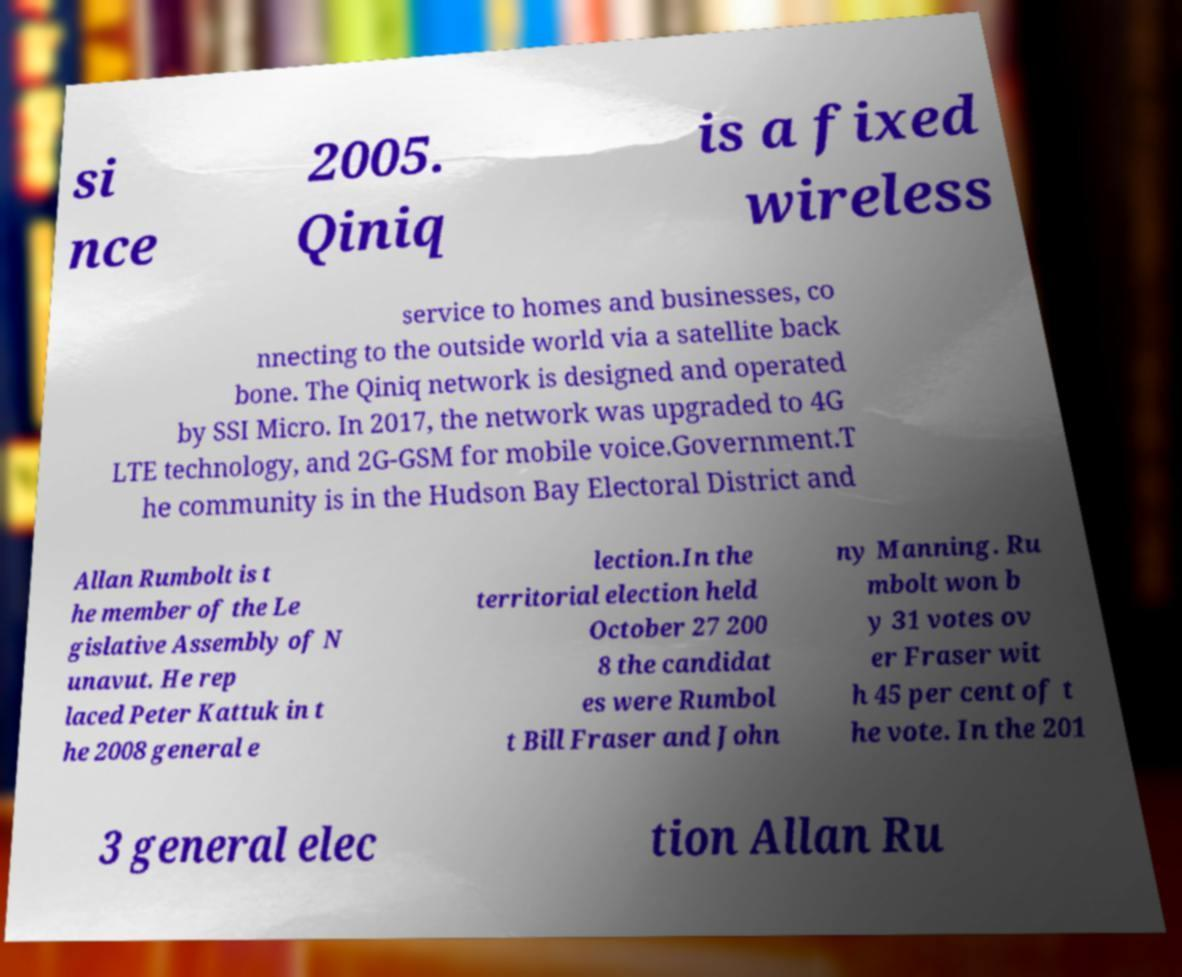Could you extract and type out the text from this image? si nce 2005. Qiniq is a fixed wireless service to homes and businesses, co nnecting to the outside world via a satellite back bone. The Qiniq network is designed and operated by SSI Micro. In 2017, the network was upgraded to 4G LTE technology, and 2G-GSM for mobile voice.Government.T he community is in the Hudson Bay Electoral District and Allan Rumbolt is t he member of the Le gislative Assembly of N unavut. He rep laced Peter Kattuk in t he 2008 general e lection.In the territorial election held October 27 200 8 the candidat es were Rumbol t Bill Fraser and John ny Manning. Ru mbolt won b y 31 votes ov er Fraser wit h 45 per cent of t he vote. In the 201 3 general elec tion Allan Ru 